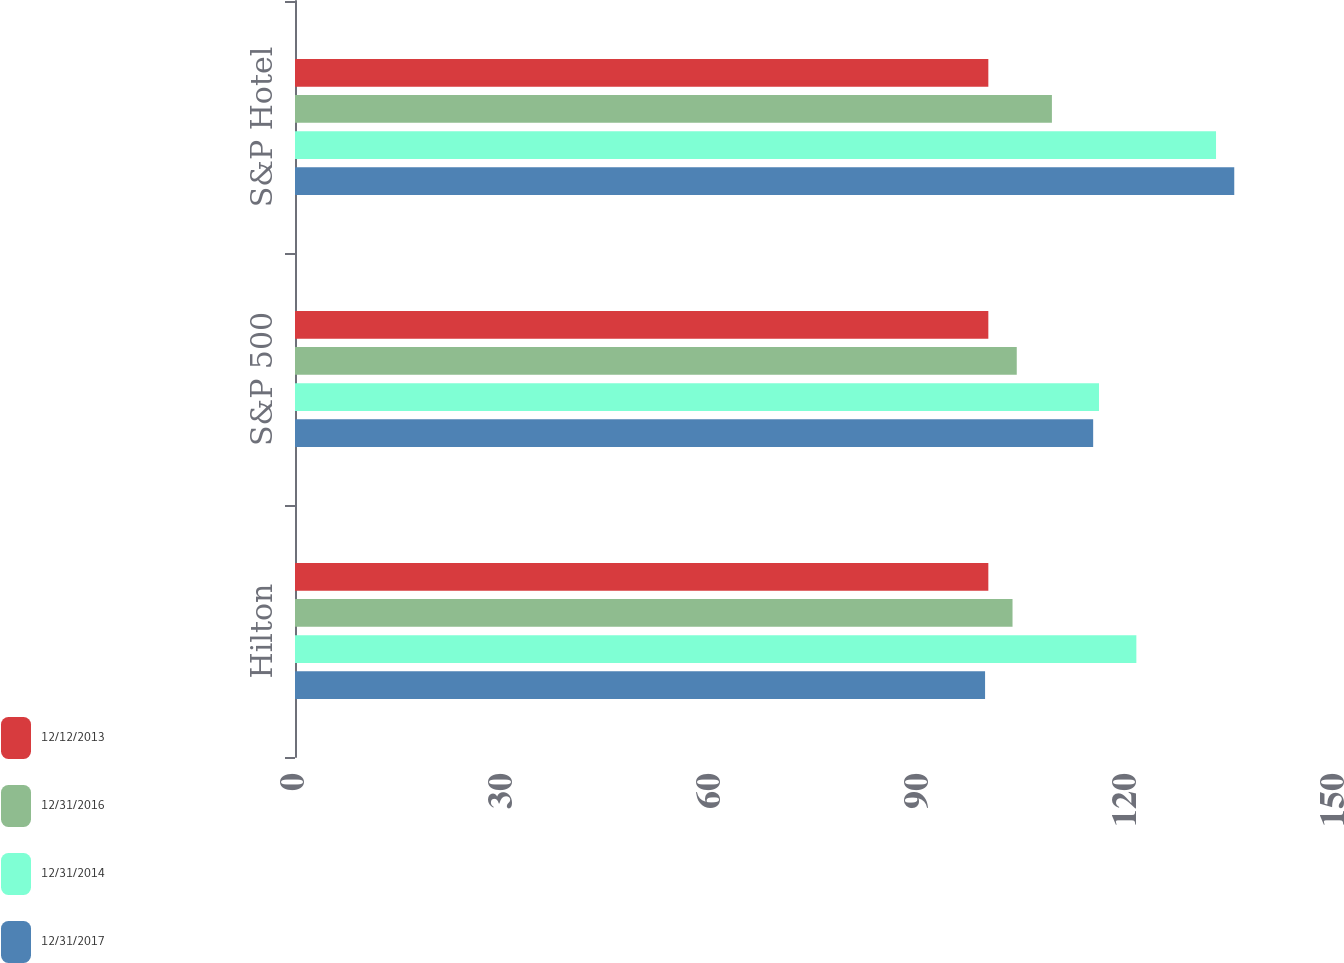<chart> <loc_0><loc_0><loc_500><loc_500><stacked_bar_chart><ecel><fcel>Hilton<fcel>S&P 500<fcel>S&P Hotel<nl><fcel>12/12/2013<fcel>100<fcel>100<fcel>100<nl><fcel>12/31/2016<fcel>103.49<fcel>104.1<fcel>109.17<nl><fcel>12/31/2014<fcel>121.35<fcel>115.96<fcel>132.84<nl><fcel>12/31/2017<fcel>99.53<fcel>115.12<fcel>135.47<nl></chart> 